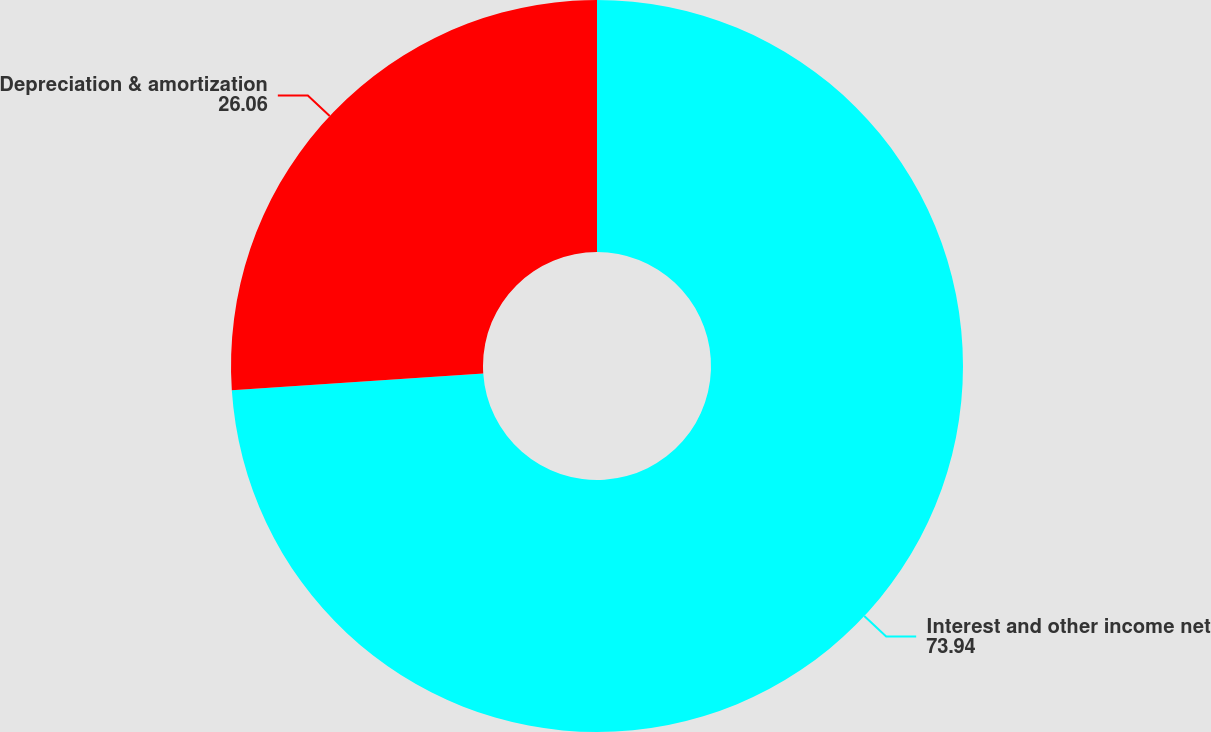<chart> <loc_0><loc_0><loc_500><loc_500><pie_chart><fcel>Interest and other income net<fcel>Depreciation & amortization<nl><fcel>73.94%<fcel>26.06%<nl></chart> 